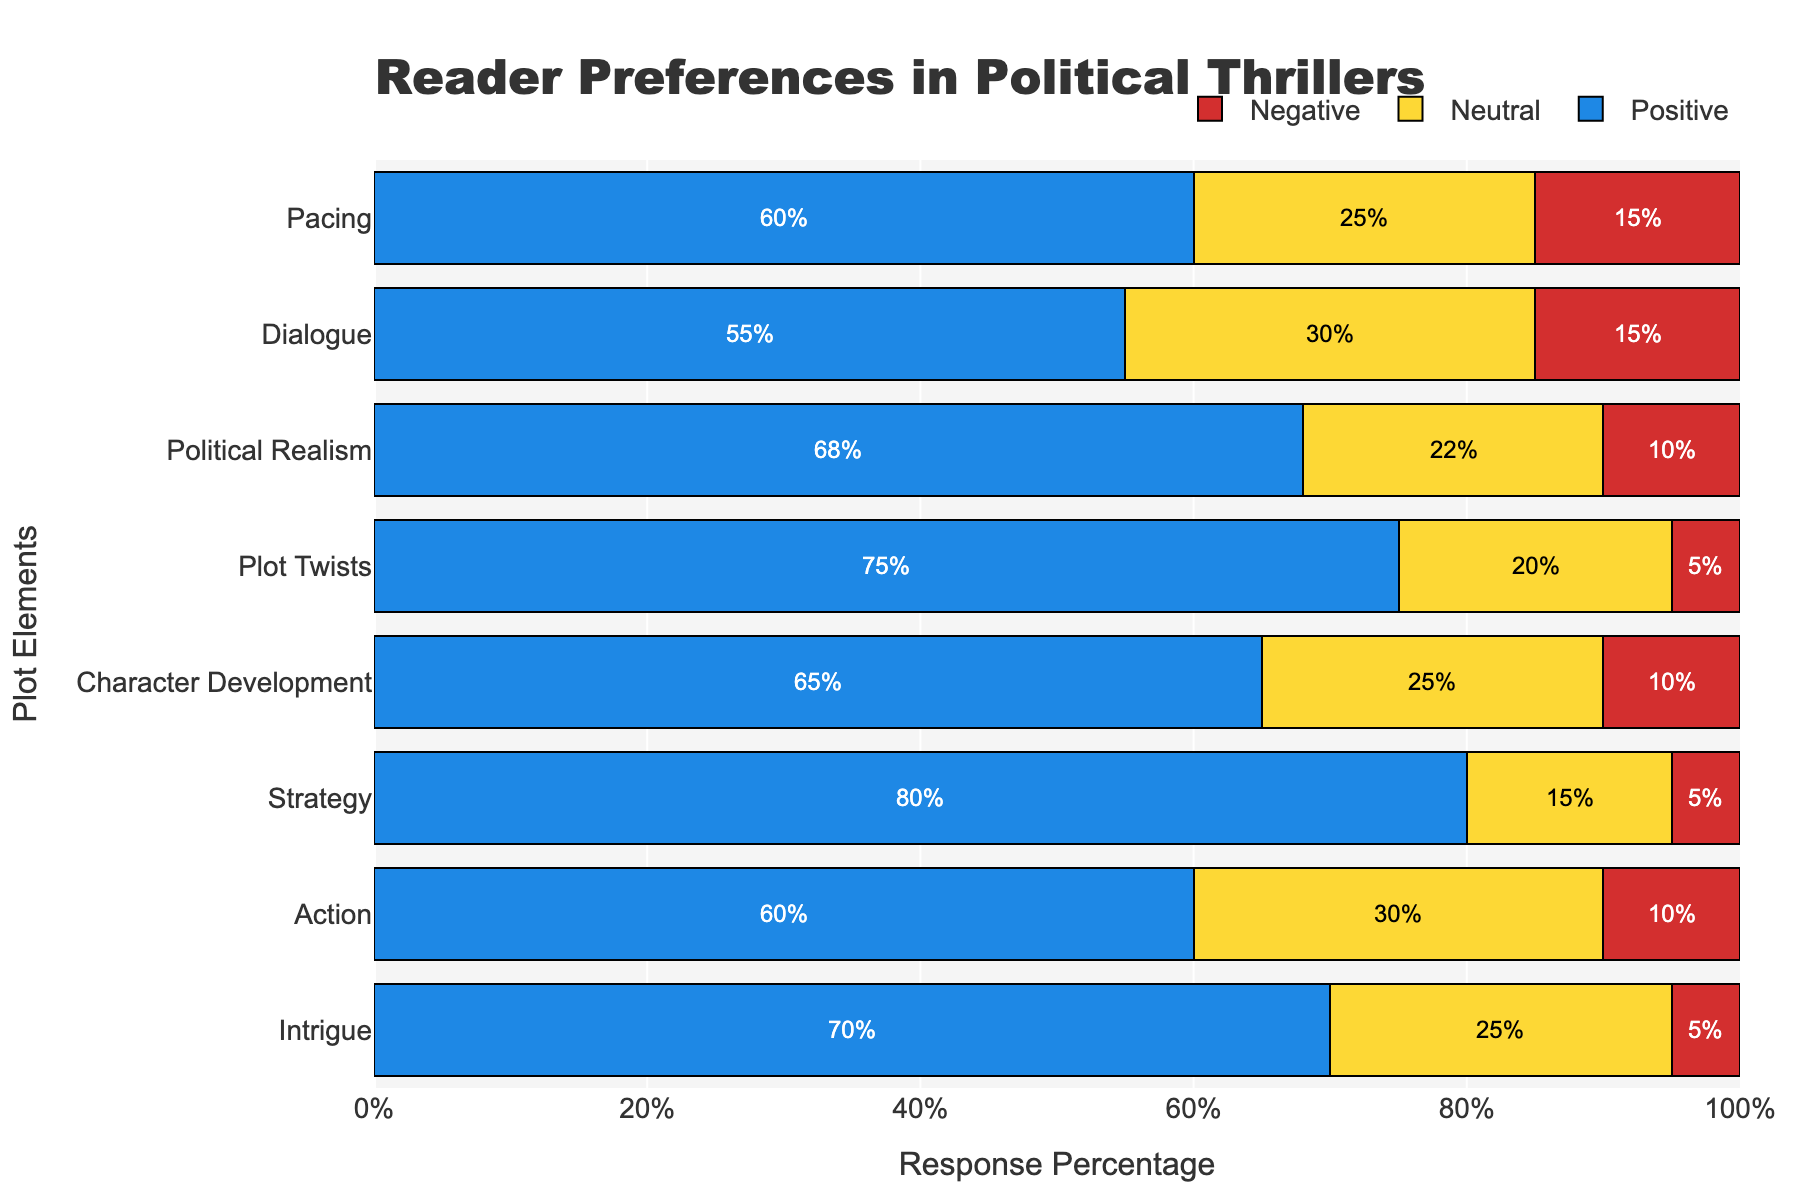What plot element had the highest positive response? By looking at the height (or length in horizontal bars) of the blue bars representing positive responses, we can identify that the 'Strategy' element has the highest positive response at 80%.
Answer: Strategy Which plot element had the lowest negative response? Observing the red bars, we can see that 'Intrigue', 'Strategy', and 'Plot Twists' all have the lowest negative response at 5%.
Answer: Intrigue, Strategy, Plot Twists What’s the sum of the neutral responses for 'Intrigue' and 'Political Realism'? The neutral response for 'Intrigue' is 25% and for 'Political Realism' is 22%. Adding them together: 25% + 22% = 47%.
Answer: 47% How does the positive response for 'Action' compare to the positive response for 'Dialogue'? The positive response for 'Action' is 60%, while for 'Dialogue' it is 55%. Therefore, 'Action' has a higher positive response than 'Dialogue' by 5%.
Answer: Action is higher by 5% Which plot element had the largest combined neutral and negative response? To find this, we need to sum the neutral and negative responses for each plot element. 'Dialogue' has 30% neutral + 15% negative = 45%, and none of the other elements exceed this combined percentage.
Answer: Dialogue What is the average positive response for 'Pacing', 'Character Development', and 'Strategy'? Calculating the average involves summing the positive responses and dividing by the number of elements. For these three: (60% + 65% + 80%) / 3 = 205% / 3 ≈ 68.33%.
Answer: 68.33% Which plot element had a higher neutral response: 'Political Realism' or 'Pacing'? 'Political Realism' has a neutral response of 22%, while 'Pacing' has a neutral response of 25%. Therefore, 'Pacing' has a higher neutral response.
Answer: Pacing What’s the total percentage of negative responses across all plot elements? We add all the negative responses together: 5% (Intrigue) + 10% (Action) + 5% (Strategy) + 10% (Character Development) + 5% (Plot Twists) + 10% (Political Realism) + 15% (Dialogue) + 15% (Pacing) = 75%.
Answer: 75% Which two plot elements had the closest neutral responses? By examining the neutral responses: 'Intrigue' (25%), 'Action' (30%), 'Strategy' (15%), 'Character Development' (25%), 'Plot Twists' (20%), 'Political Realism' (22%), 'Dialogue' (30%), 'Pacing' (25%), we see that 'Intrigue', 'Character Development', and 'Pacing' all have neutral responses of 25%.
Answer: Intrigue, Character Development, Pacing 